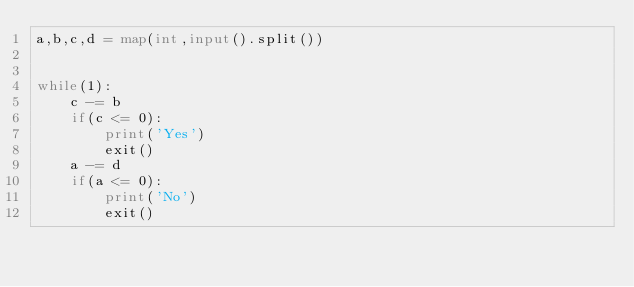Convert code to text. <code><loc_0><loc_0><loc_500><loc_500><_Python_>a,b,c,d = map(int,input().split())


while(1):
    c -= b
    if(c <= 0):
        print('Yes')
        exit()
    a -= d
    if(a <= 0):
        print('No')
        exit()</code> 